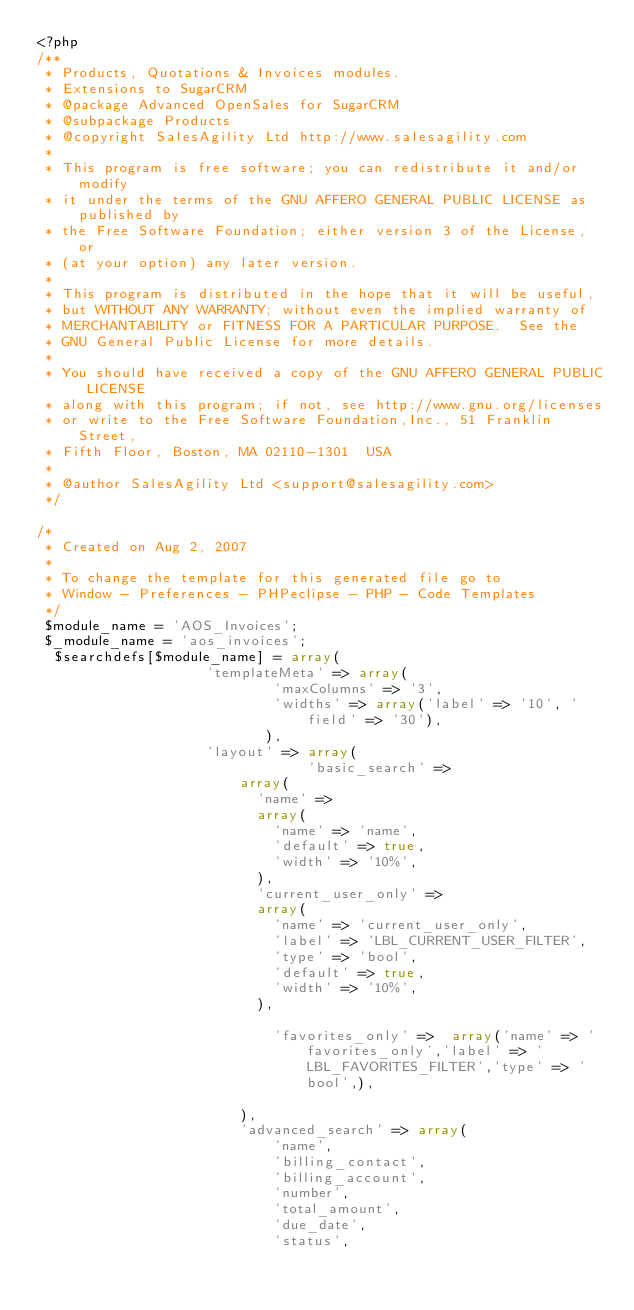Convert code to text. <code><loc_0><loc_0><loc_500><loc_500><_PHP_><?php
/**
 * Products, Quotations & Invoices modules.
 * Extensions to SugarCRM
 * @package Advanced OpenSales for SugarCRM
 * @subpackage Products
 * @copyright SalesAgility Ltd http://www.salesagility.com
 *
 * This program is free software; you can redistribute it and/or modify
 * it under the terms of the GNU AFFERO GENERAL PUBLIC LICENSE as published by
 * the Free Software Foundation; either version 3 of the License, or
 * (at your option) any later version.
 *
 * This program is distributed in the hope that it will be useful,
 * but WITHOUT ANY WARRANTY; without even the implied warranty of
 * MERCHANTABILITY or FITNESS FOR A PARTICULAR PURPOSE.  See the
 * GNU General Public License for more details.
 *
 * You should have received a copy of the GNU AFFERO GENERAL PUBLIC LICENSE
 * along with this program; if not, see http://www.gnu.org/licenses
 * or write to the Free Software Foundation,Inc., 51 Franklin Street,
 * Fifth Floor, Boston, MA 02110-1301  USA
 *
 * @author SalesAgility Ltd <support@salesagility.com>
 */

/*
 * Created on Aug 2, 2007
 *
 * To change the template for this generated file go to
 * Window - Preferences - PHPeclipse - PHP - Code Templates
 */
 $module_name = 'AOS_Invoices';
 $_module_name = 'aos_invoices';
  $searchdefs[$module_name] = array(
                    'templateMeta' => array(
                            'maxColumns' => '3',
                            'widths' => array('label' => '10', 'field' => '30'),
                           ),
                    'layout' => array(
                                'basic_search' =>
                        array(
                          'name' =>
                          array(
                            'name' => 'name',
                            'default' => true,
                            'width' => '10%',
                          ),
                          'current_user_only' =>
                          array(
                            'name' => 'current_user_only',
                            'label' => 'LBL_CURRENT_USER_FILTER',
                            'type' => 'bool',
                            'default' => true,
                            'width' => '10%',
                          ),

                            'favorites_only' =>  array('name' => 'favorites_only','label' => 'LBL_FAVORITES_FILTER','type' => 'bool',),
                          
                        ),
                        'advanced_search' => array(
                            'name',
                            'billing_contact',
                            'billing_account',
                            'number',
                            'total_amount',
                            'due_date',
                            'status',</code> 